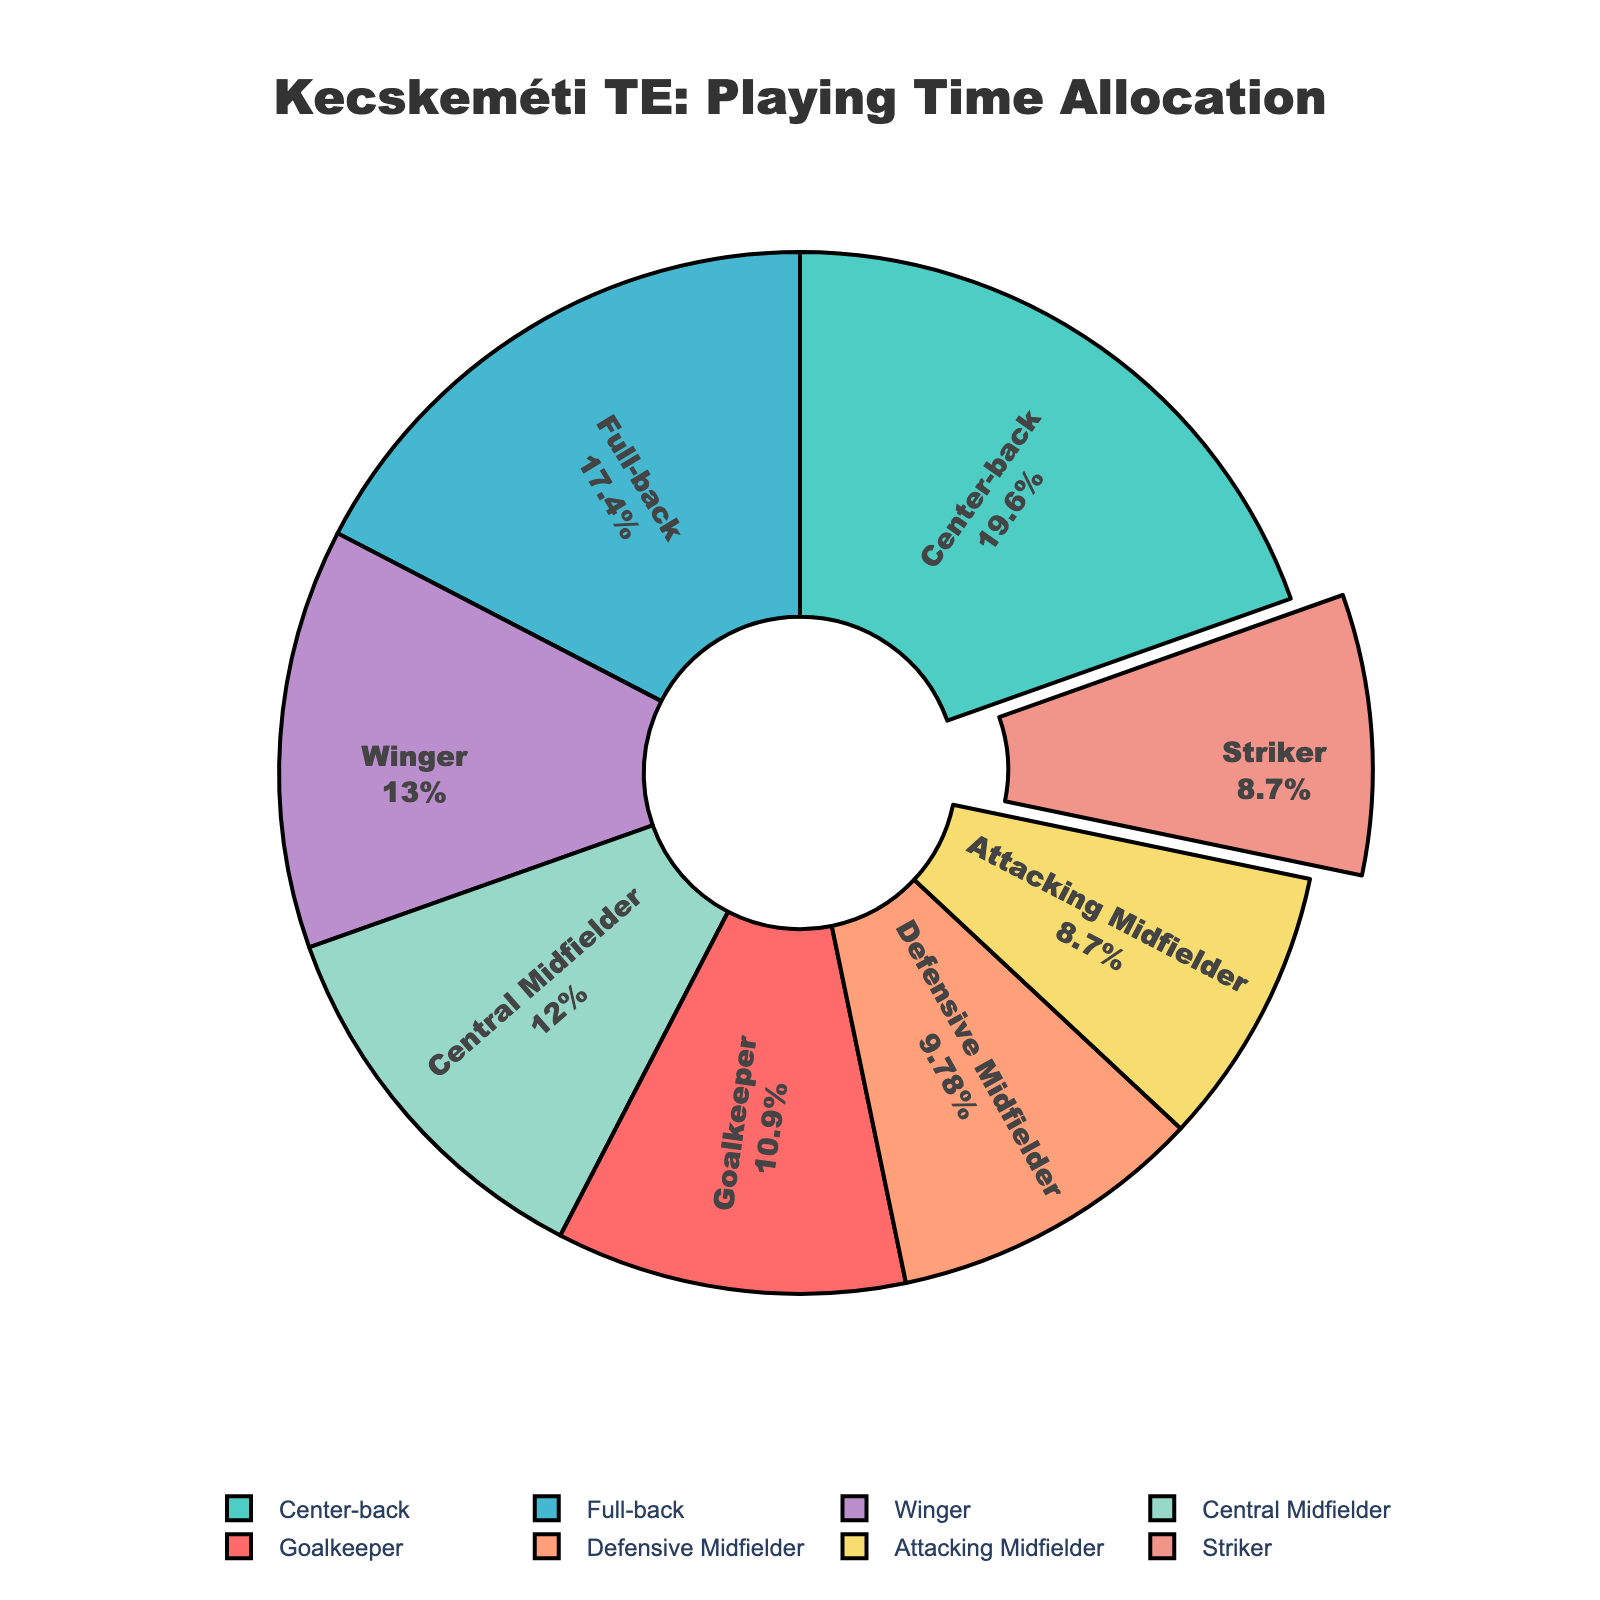Which position has the highest playing time allocation? The pie chart shows that Center-back has the largest segment.
Answer: Center-back Which position shares the same allocation percentage with the Striker? Both Attacking Midfielder and Striker have the same size of pie segments.
Answer: Attacking Midfielder What's the total playing time for Full-back and Winger combined? Full-back has 1440 minutes, and Winger has 1080 minutes. Adding these gives 1440 + 1080 = 2520 minutes.
Answer: 2520 minutes What is the difference in playing time between Central Midfielder and Defensive Midfielder? Central Midfielder has 990 minutes, and Defensive Midfielder has 810 minutes. The difference is 990 - 810 = 180 minutes.
Answer: 180 minutes If Defensive Midfielder had 300 more minutes, would it have the same allocation as Winger? Defensive Midfielder’s minutes would become 810 + 300 = 1110 minutes, which is slightly more than Winger’s 1080 minutes.
Answer: No Which position's segment is highlighted/pulled out in the pie chart? The pie chart visually highlights the position of Striker.
Answer: Striker Is the percentage of playing time allocation for Attacking Midfielder more, less, or equal to that of Goalkeeper? The Attacking Midfielder and Goalkeeper segments are of different sizes. The Attacking Midfielder has a smaller segment.
Answer: Less What two positions collectively account for more than half of the total playing time? Center-back (1620) and Full-back (1440) together make 1620 + 1440 = 3060 minutes, which is more than half of the total.
Answer: Center-back and Full-back 